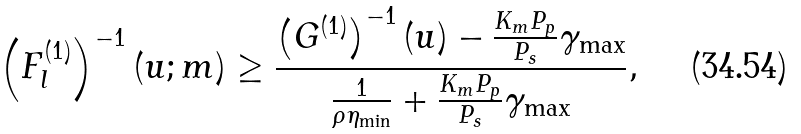<formula> <loc_0><loc_0><loc_500><loc_500>\left ( F _ { l } ^ { ( 1 ) } \right ) ^ { - 1 } ( u ; m ) \geq \frac { \left ( G ^ { ( 1 ) } \right ) ^ { - 1 } ( u ) - \frac { K _ { m } P _ { p } } { P _ { s } } \gamma _ { \max } } { \frac { 1 } { \rho \eta _ { \min } } + \frac { K _ { m } P _ { p } } { P _ { s } } \gamma _ { \max } } ,</formula> 